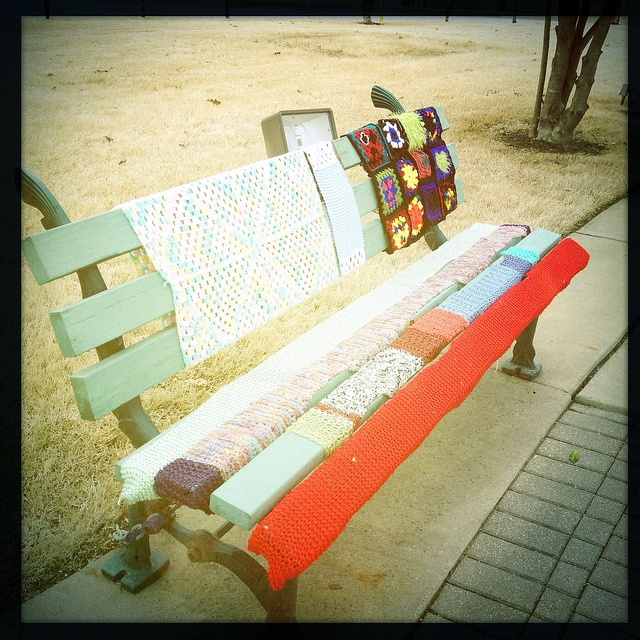Describe the objects in this image and their specific colors. I can see a bench in black, ivory, khaki, red, and lightgreen tones in this image. 